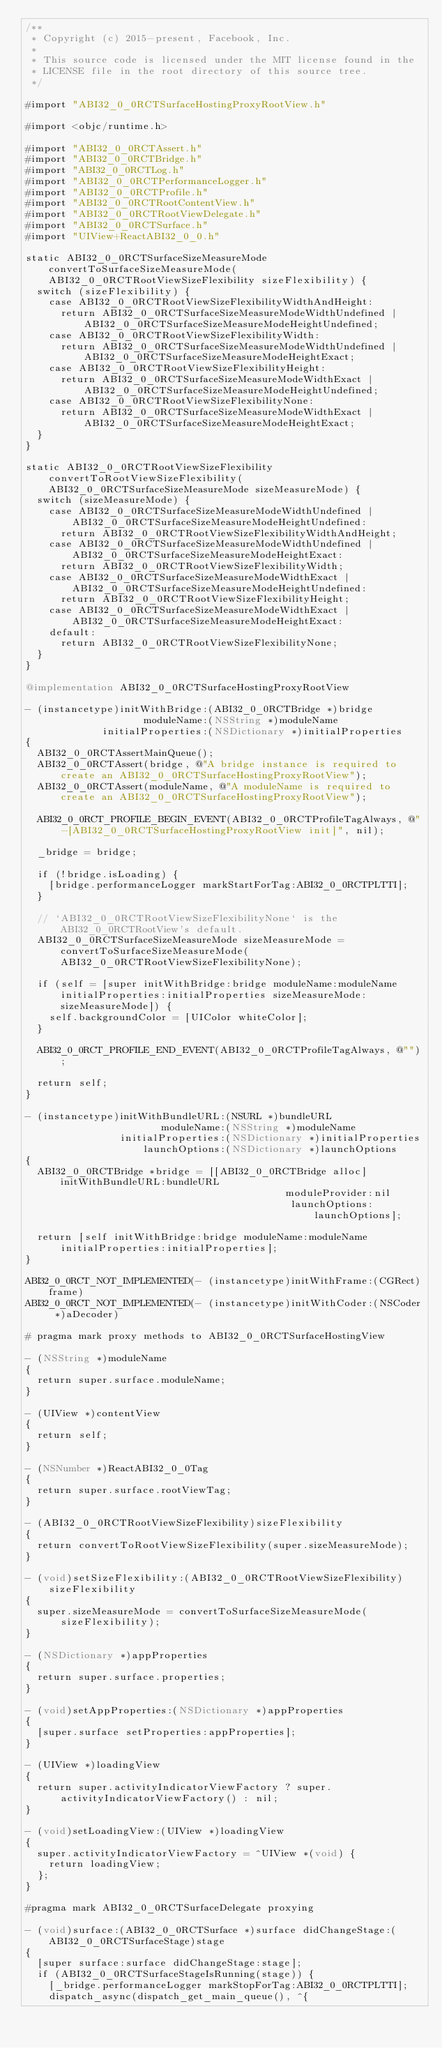Convert code to text. <code><loc_0><loc_0><loc_500><loc_500><_ObjectiveC_>/**
 * Copyright (c) 2015-present, Facebook, Inc.
 *
 * This source code is licensed under the MIT license found in the
 * LICENSE file in the root directory of this source tree.
 */

#import "ABI32_0_0RCTSurfaceHostingProxyRootView.h"

#import <objc/runtime.h>

#import "ABI32_0_0RCTAssert.h"
#import "ABI32_0_0RCTBridge.h"
#import "ABI32_0_0RCTLog.h"
#import "ABI32_0_0RCTPerformanceLogger.h"
#import "ABI32_0_0RCTProfile.h"
#import "ABI32_0_0RCTRootContentView.h"
#import "ABI32_0_0RCTRootViewDelegate.h"
#import "ABI32_0_0RCTSurface.h"
#import "UIView+ReactABI32_0_0.h"

static ABI32_0_0RCTSurfaceSizeMeasureMode convertToSurfaceSizeMeasureMode(ABI32_0_0RCTRootViewSizeFlexibility sizeFlexibility) {
  switch (sizeFlexibility) {
    case ABI32_0_0RCTRootViewSizeFlexibilityWidthAndHeight:
      return ABI32_0_0RCTSurfaceSizeMeasureModeWidthUndefined | ABI32_0_0RCTSurfaceSizeMeasureModeHeightUndefined;
    case ABI32_0_0RCTRootViewSizeFlexibilityWidth:
      return ABI32_0_0RCTSurfaceSizeMeasureModeWidthUndefined | ABI32_0_0RCTSurfaceSizeMeasureModeHeightExact;
    case ABI32_0_0RCTRootViewSizeFlexibilityHeight:
      return ABI32_0_0RCTSurfaceSizeMeasureModeWidthExact | ABI32_0_0RCTSurfaceSizeMeasureModeHeightUndefined;
    case ABI32_0_0RCTRootViewSizeFlexibilityNone:
      return ABI32_0_0RCTSurfaceSizeMeasureModeWidthExact | ABI32_0_0RCTSurfaceSizeMeasureModeHeightExact;
  }
}

static ABI32_0_0RCTRootViewSizeFlexibility convertToRootViewSizeFlexibility(ABI32_0_0RCTSurfaceSizeMeasureMode sizeMeasureMode) {
  switch (sizeMeasureMode) {
    case ABI32_0_0RCTSurfaceSizeMeasureModeWidthUndefined | ABI32_0_0RCTSurfaceSizeMeasureModeHeightUndefined:
      return ABI32_0_0RCTRootViewSizeFlexibilityWidthAndHeight;
    case ABI32_0_0RCTSurfaceSizeMeasureModeWidthUndefined | ABI32_0_0RCTSurfaceSizeMeasureModeHeightExact:
      return ABI32_0_0RCTRootViewSizeFlexibilityWidth;
    case ABI32_0_0RCTSurfaceSizeMeasureModeWidthExact | ABI32_0_0RCTSurfaceSizeMeasureModeHeightUndefined:
      return ABI32_0_0RCTRootViewSizeFlexibilityHeight;
    case ABI32_0_0RCTSurfaceSizeMeasureModeWidthExact | ABI32_0_0RCTSurfaceSizeMeasureModeHeightExact:
    default:
      return ABI32_0_0RCTRootViewSizeFlexibilityNone;
  }
}

@implementation ABI32_0_0RCTSurfaceHostingProxyRootView

- (instancetype)initWithBridge:(ABI32_0_0RCTBridge *)bridge
                    moduleName:(NSString *)moduleName
             initialProperties:(NSDictionary *)initialProperties
{
  ABI32_0_0RCTAssertMainQueue();
  ABI32_0_0RCTAssert(bridge, @"A bridge instance is required to create an ABI32_0_0RCTSurfaceHostingProxyRootView");
  ABI32_0_0RCTAssert(moduleName, @"A moduleName is required to create an ABI32_0_0RCTSurfaceHostingProxyRootView");

  ABI32_0_0RCT_PROFILE_BEGIN_EVENT(ABI32_0_0RCTProfileTagAlways, @"-[ABI32_0_0RCTSurfaceHostingProxyRootView init]", nil);

  _bridge = bridge;

  if (!bridge.isLoading) {
    [bridge.performanceLogger markStartForTag:ABI32_0_0RCTPLTTI];
  }

  // `ABI32_0_0RCTRootViewSizeFlexibilityNone` is the ABI32_0_0RCTRootView's default.
  ABI32_0_0RCTSurfaceSizeMeasureMode sizeMeasureMode = convertToSurfaceSizeMeasureMode(ABI32_0_0RCTRootViewSizeFlexibilityNone);

  if (self = [super initWithBridge:bridge moduleName:moduleName initialProperties:initialProperties sizeMeasureMode:sizeMeasureMode]) {
    self.backgroundColor = [UIColor whiteColor];
  }

  ABI32_0_0RCT_PROFILE_END_EVENT(ABI32_0_0RCTProfileTagAlways, @"");

  return self;
}

- (instancetype)initWithBundleURL:(NSURL *)bundleURL
                       moduleName:(NSString *)moduleName
                initialProperties:(NSDictionary *)initialProperties
                    launchOptions:(NSDictionary *)launchOptions
{
  ABI32_0_0RCTBridge *bridge = [[ABI32_0_0RCTBridge alloc] initWithBundleURL:bundleURL
                                            moduleProvider:nil
                                             launchOptions:launchOptions];

  return [self initWithBridge:bridge moduleName:moduleName initialProperties:initialProperties];
}

ABI32_0_0RCT_NOT_IMPLEMENTED(- (instancetype)initWithFrame:(CGRect)frame)
ABI32_0_0RCT_NOT_IMPLEMENTED(- (instancetype)initWithCoder:(NSCoder *)aDecoder)

# pragma mark proxy methods to ABI32_0_0RCTSurfaceHostingView

- (NSString *)moduleName
{
  return super.surface.moduleName;
}

- (UIView *)contentView
{
  return self;
}

- (NSNumber *)ReactABI32_0_0Tag
{
  return super.surface.rootViewTag;
}

- (ABI32_0_0RCTRootViewSizeFlexibility)sizeFlexibility
{
  return convertToRootViewSizeFlexibility(super.sizeMeasureMode);
}

- (void)setSizeFlexibility:(ABI32_0_0RCTRootViewSizeFlexibility)sizeFlexibility
{
  super.sizeMeasureMode = convertToSurfaceSizeMeasureMode(sizeFlexibility);
}

- (NSDictionary *)appProperties
{
  return super.surface.properties;
}

- (void)setAppProperties:(NSDictionary *)appProperties
{
  [super.surface setProperties:appProperties];
}

- (UIView *)loadingView
{
  return super.activityIndicatorViewFactory ? super.activityIndicatorViewFactory() : nil;
}

- (void)setLoadingView:(UIView *)loadingView
{
  super.activityIndicatorViewFactory = ^UIView *(void) {
    return loadingView;
  };
}

#pragma mark ABI32_0_0RCTSurfaceDelegate proxying

- (void)surface:(ABI32_0_0RCTSurface *)surface didChangeStage:(ABI32_0_0RCTSurfaceStage)stage
{
  [super surface:surface didChangeStage:stage];
  if (ABI32_0_0RCTSurfaceStageIsRunning(stage)) {
    [_bridge.performanceLogger markStopForTag:ABI32_0_0RCTPLTTI];
    dispatch_async(dispatch_get_main_queue(), ^{</code> 